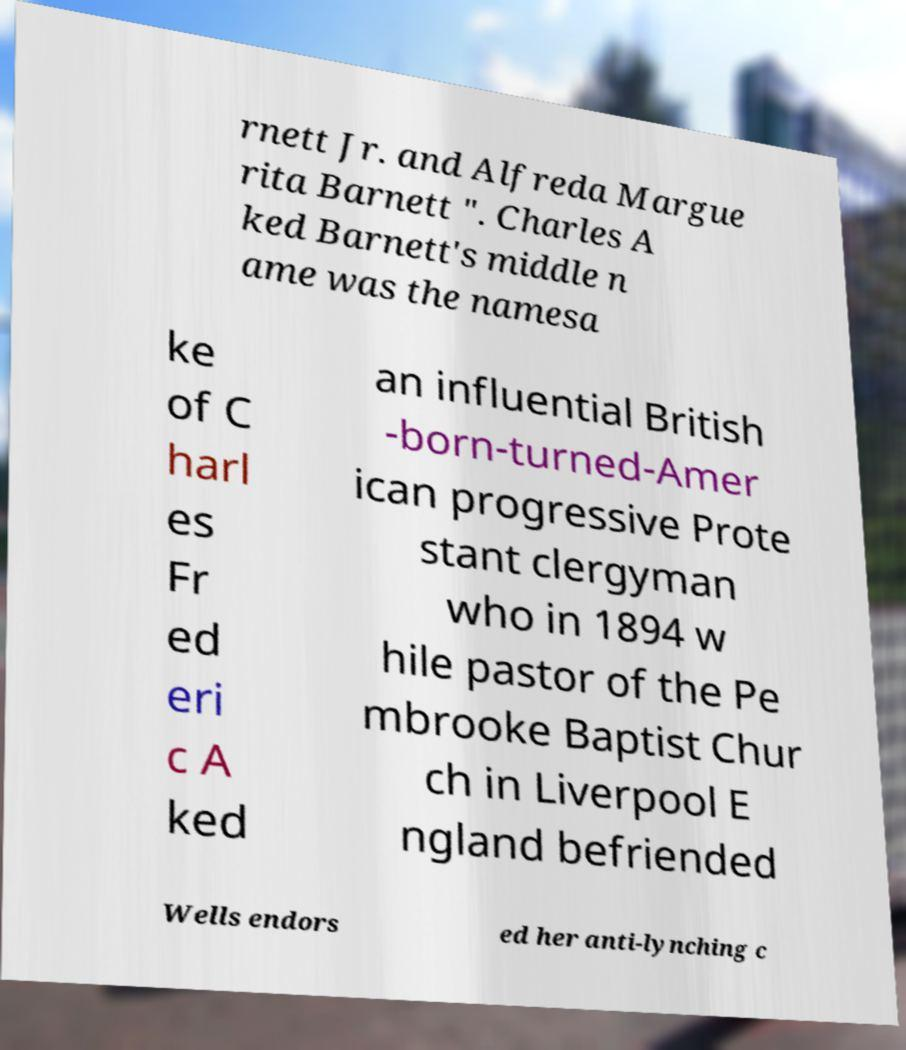Could you assist in decoding the text presented in this image and type it out clearly? rnett Jr. and Alfreda Margue rita Barnett ". Charles A ked Barnett's middle n ame was the namesa ke of C harl es Fr ed eri c A ked an influential British -born-turned-Amer ican progressive Prote stant clergyman who in 1894 w hile pastor of the Pe mbrooke Baptist Chur ch in Liverpool E ngland befriended Wells endors ed her anti-lynching c 